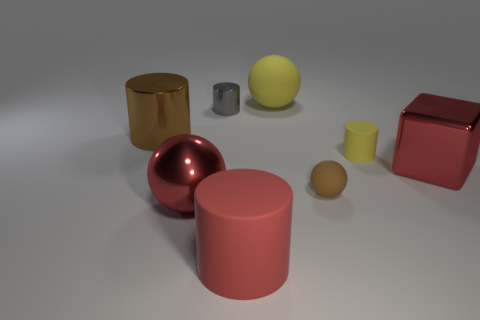Subtract all blue cylinders. Subtract all blue cubes. How many cylinders are left? 4 Add 1 small gray cylinders. How many objects exist? 9 Subtract all spheres. How many objects are left? 5 Add 7 red things. How many red things exist? 10 Subtract 1 yellow cylinders. How many objects are left? 7 Subtract all metal balls. Subtract all small balls. How many objects are left? 6 Add 4 tiny gray cylinders. How many tiny gray cylinders are left? 5 